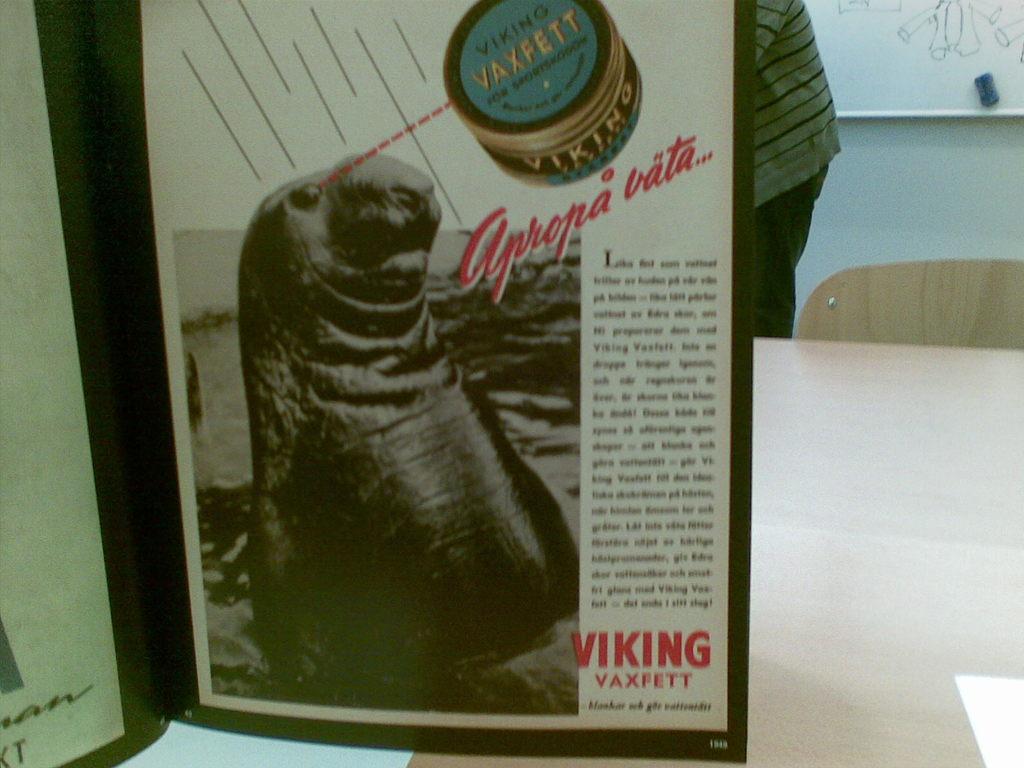What is the name of the product in this magazine?
Offer a very short reply. Vaxfett. 